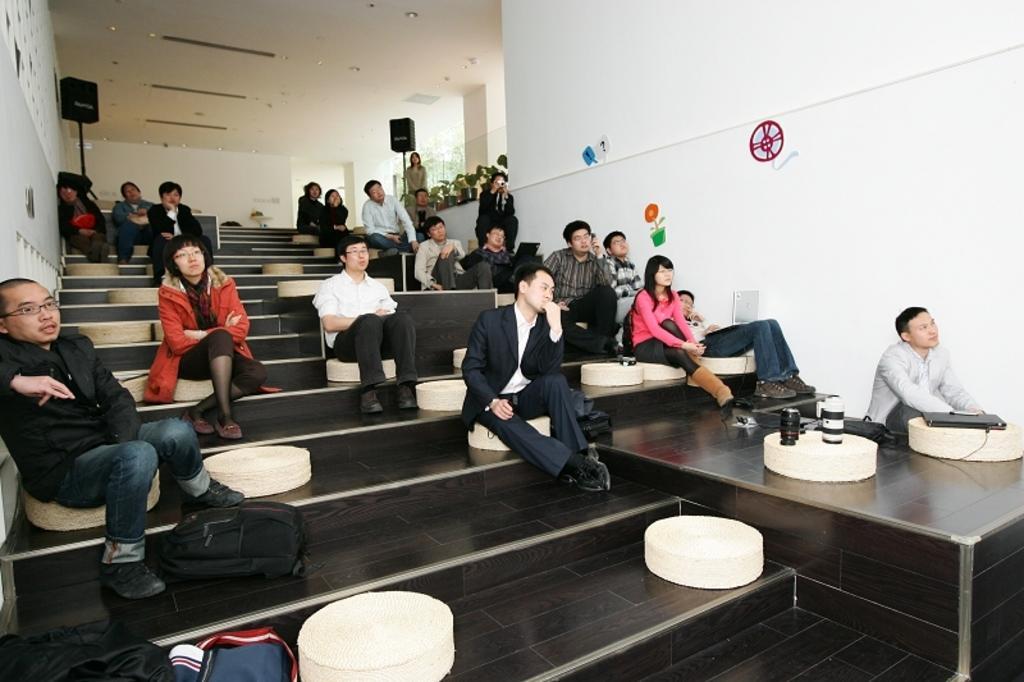Could you give a brief overview of what you see in this image? This image is taken indoors. In the background there are a few walls and there are a few pillars. There are a few paintings on the wall. At the top of the image there is a ceiling with a few lights. There are two speaker boxes. In the middle of the image many people are sitting on the seats. At the bottom of the image there is a floor and there are many backpacks on the stairs. There are a few plants in the pots and a woman is standing on the floor. 